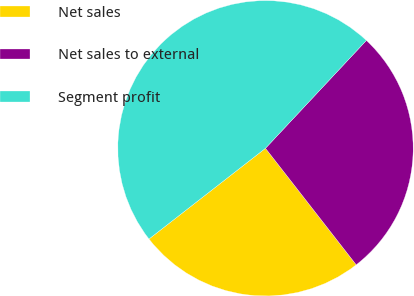<chart> <loc_0><loc_0><loc_500><loc_500><pie_chart><fcel>Net sales<fcel>Net sales to external<fcel>Segment profit<nl><fcel>25.0%<fcel>27.5%<fcel>47.5%<nl></chart> 